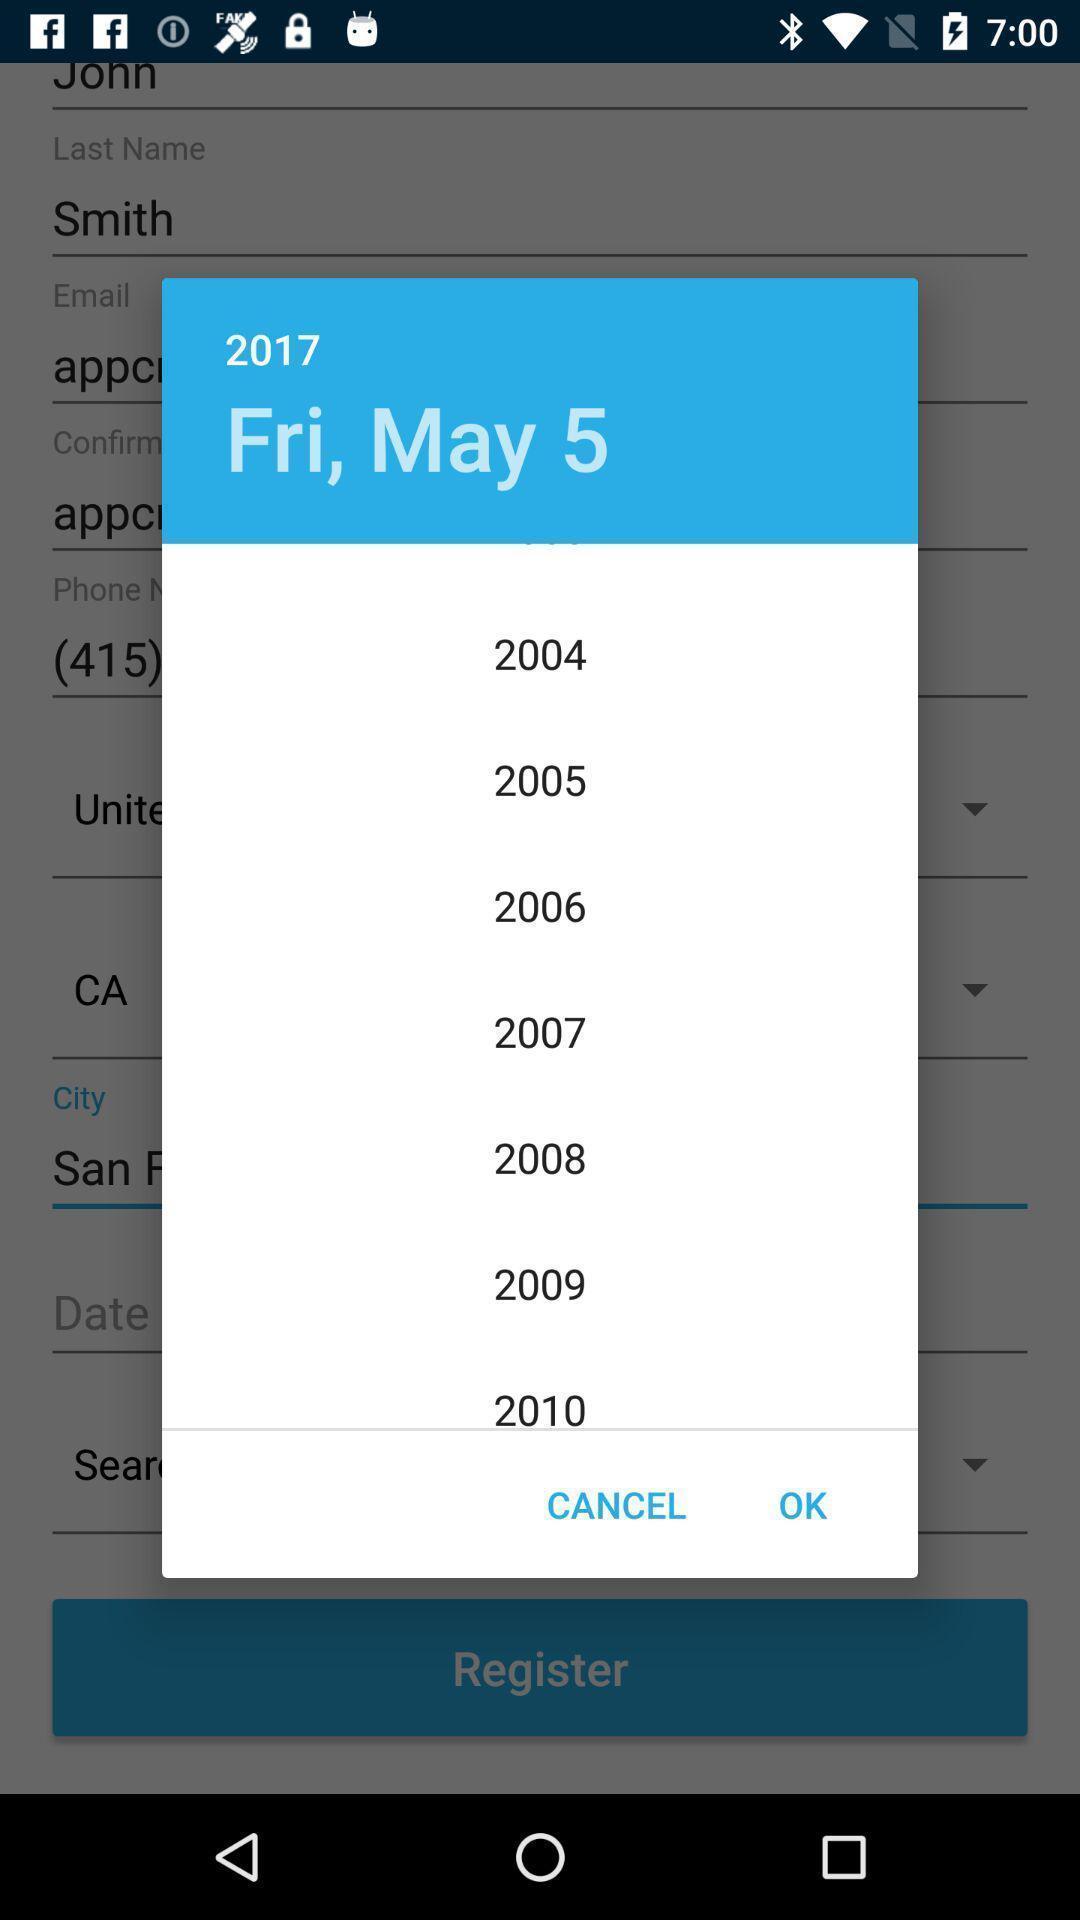Summarize the main components in this picture. Popup displaying list of years information. 